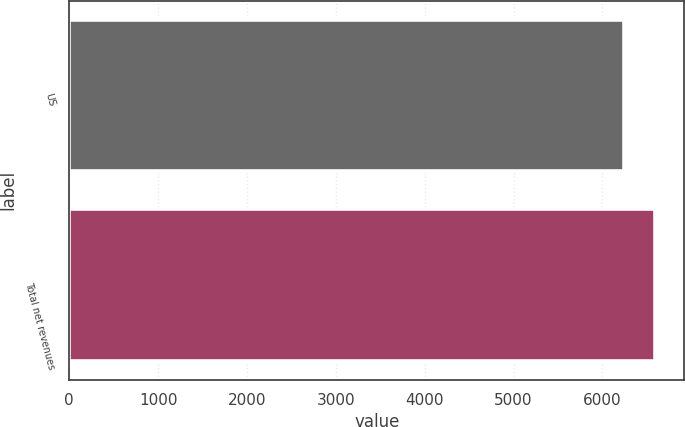Convert chart. <chart><loc_0><loc_0><loc_500><loc_500><bar_chart><fcel>US<fcel>Total net revenues<nl><fcel>6246.1<fcel>6593.9<nl></chart> 